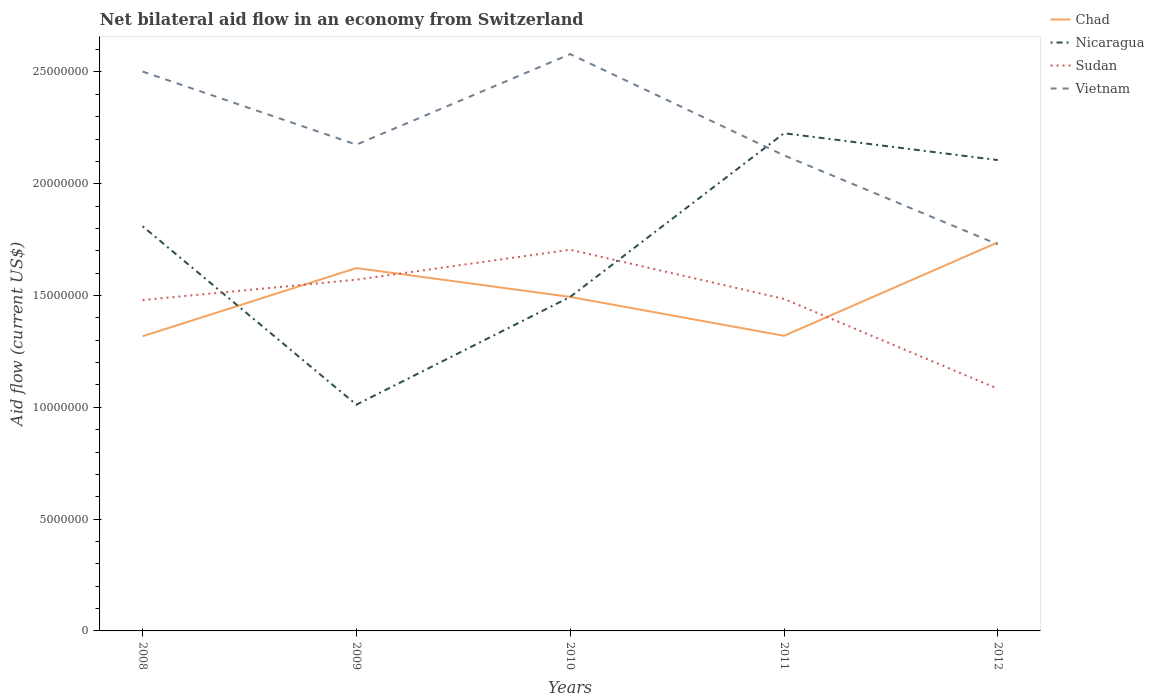How many different coloured lines are there?
Offer a very short reply. 4. Does the line corresponding to Nicaragua intersect with the line corresponding to Chad?
Keep it short and to the point. Yes. Across all years, what is the maximum net bilateral aid flow in Sudan?
Your response must be concise. 1.08e+07. In which year was the net bilateral aid flow in Nicaragua maximum?
Give a very brief answer. 2009. What is the total net bilateral aid flow in Nicaragua in the graph?
Your answer should be compact. 7.98e+06. What is the difference between the highest and the second highest net bilateral aid flow in Chad?
Your answer should be compact. 4.20e+06. How many lines are there?
Offer a very short reply. 4. Are the values on the major ticks of Y-axis written in scientific E-notation?
Your answer should be very brief. No. Does the graph contain any zero values?
Make the answer very short. No. Does the graph contain grids?
Provide a short and direct response. No. How many legend labels are there?
Make the answer very short. 4. What is the title of the graph?
Give a very brief answer. Net bilateral aid flow in an economy from Switzerland. Does "Ethiopia" appear as one of the legend labels in the graph?
Your answer should be very brief. No. What is the label or title of the X-axis?
Your answer should be very brief. Years. What is the Aid flow (current US$) of Chad in 2008?
Give a very brief answer. 1.32e+07. What is the Aid flow (current US$) of Nicaragua in 2008?
Your answer should be compact. 1.81e+07. What is the Aid flow (current US$) in Sudan in 2008?
Provide a short and direct response. 1.48e+07. What is the Aid flow (current US$) of Vietnam in 2008?
Give a very brief answer. 2.50e+07. What is the Aid flow (current US$) of Chad in 2009?
Keep it short and to the point. 1.62e+07. What is the Aid flow (current US$) of Nicaragua in 2009?
Your answer should be compact. 1.01e+07. What is the Aid flow (current US$) in Sudan in 2009?
Keep it short and to the point. 1.57e+07. What is the Aid flow (current US$) in Vietnam in 2009?
Ensure brevity in your answer.  2.18e+07. What is the Aid flow (current US$) in Chad in 2010?
Provide a succinct answer. 1.49e+07. What is the Aid flow (current US$) in Nicaragua in 2010?
Your response must be concise. 1.49e+07. What is the Aid flow (current US$) in Sudan in 2010?
Provide a succinct answer. 1.70e+07. What is the Aid flow (current US$) in Vietnam in 2010?
Keep it short and to the point. 2.58e+07. What is the Aid flow (current US$) of Chad in 2011?
Offer a very short reply. 1.32e+07. What is the Aid flow (current US$) in Nicaragua in 2011?
Provide a succinct answer. 2.23e+07. What is the Aid flow (current US$) in Sudan in 2011?
Offer a very short reply. 1.48e+07. What is the Aid flow (current US$) in Vietnam in 2011?
Offer a terse response. 2.13e+07. What is the Aid flow (current US$) of Chad in 2012?
Your response must be concise. 1.74e+07. What is the Aid flow (current US$) in Nicaragua in 2012?
Your answer should be compact. 2.11e+07. What is the Aid flow (current US$) in Sudan in 2012?
Provide a succinct answer. 1.08e+07. What is the Aid flow (current US$) in Vietnam in 2012?
Keep it short and to the point. 1.73e+07. Across all years, what is the maximum Aid flow (current US$) in Chad?
Your answer should be very brief. 1.74e+07. Across all years, what is the maximum Aid flow (current US$) of Nicaragua?
Your response must be concise. 2.23e+07. Across all years, what is the maximum Aid flow (current US$) of Sudan?
Provide a short and direct response. 1.70e+07. Across all years, what is the maximum Aid flow (current US$) of Vietnam?
Offer a very short reply. 2.58e+07. Across all years, what is the minimum Aid flow (current US$) in Chad?
Your response must be concise. 1.32e+07. Across all years, what is the minimum Aid flow (current US$) of Nicaragua?
Keep it short and to the point. 1.01e+07. Across all years, what is the minimum Aid flow (current US$) in Sudan?
Keep it short and to the point. 1.08e+07. Across all years, what is the minimum Aid flow (current US$) of Vietnam?
Your response must be concise. 1.73e+07. What is the total Aid flow (current US$) in Chad in the graph?
Make the answer very short. 7.49e+07. What is the total Aid flow (current US$) in Nicaragua in the graph?
Your answer should be very brief. 8.65e+07. What is the total Aid flow (current US$) in Sudan in the graph?
Provide a short and direct response. 7.32e+07. What is the total Aid flow (current US$) of Vietnam in the graph?
Your answer should be very brief. 1.11e+08. What is the difference between the Aid flow (current US$) of Chad in 2008 and that in 2009?
Give a very brief answer. -3.05e+06. What is the difference between the Aid flow (current US$) of Nicaragua in 2008 and that in 2009?
Your answer should be compact. 7.98e+06. What is the difference between the Aid flow (current US$) in Sudan in 2008 and that in 2009?
Make the answer very short. -9.10e+05. What is the difference between the Aid flow (current US$) of Vietnam in 2008 and that in 2009?
Offer a terse response. 3.27e+06. What is the difference between the Aid flow (current US$) of Chad in 2008 and that in 2010?
Your response must be concise. -1.76e+06. What is the difference between the Aid flow (current US$) in Nicaragua in 2008 and that in 2010?
Provide a short and direct response. 3.16e+06. What is the difference between the Aid flow (current US$) of Sudan in 2008 and that in 2010?
Your response must be concise. -2.25e+06. What is the difference between the Aid flow (current US$) in Vietnam in 2008 and that in 2010?
Ensure brevity in your answer.  -7.80e+05. What is the difference between the Aid flow (current US$) of Chad in 2008 and that in 2011?
Ensure brevity in your answer.  -2.00e+04. What is the difference between the Aid flow (current US$) in Nicaragua in 2008 and that in 2011?
Your answer should be compact. -4.16e+06. What is the difference between the Aid flow (current US$) of Vietnam in 2008 and that in 2011?
Keep it short and to the point. 3.75e+06. What is the difference between the Aid flow (current US$) of Chad in 2008 and that in 2012?
Offer a terse response. -4.20e+06. What is the difference between the Aid flow (current US$) of Nicaragua in 2008 and that in 2012?
Provide a succinct answer. -2.96e+06. What is the difference between the Aid flow (current US$) in Sudan in 2008 and that in 2012?
Your answer should be very brief. 3.97e+06. What is the difference between the Aid flow (current US$) of Vietnam in 2008 and that in 2012?
Your answer should be very brief. 7.73e+06. What is the difference between the Aid flow (current US$) of Chad in 2009 and that in 2010?
Keep it short and to the point. 1.29e+06. What is the difference between the Aid flow (current US$) of Nicaragua in 2009 and that in 2010?
Your answer should be very brief. -4.82e+06. What is the difference between the Aid flow (current US$) of Sudan in 2009 and that in 2010?
Make the answer very short. -1.34e+06. What is the difference between the Aid flow (current US$) of Vietnam in 2009 and that in 2010?
Offer a terse response. -4.05e+06. What is the difference between the Aid flow (current US$) in Chad in 2009 and that in 2011?
Give a very brief answer. 3.03e+06. What is the difference between the Aid flow (current US$) in Nicaragua in 2009 and that in 2011?
Provide a short and direct response. -1.21e+07. What is the difference between the Aid flow (current US$) of Sudan in 2009 and that in 2011?
Your answer should be compact. 8.60e+05. What is the difference between the Aid flow (current US$) in Chad in 2009 and that in 2012?
Offer a terse response. -1.15e+06. What is the difference between the Aid flow (current US$) in Nicaragua in 2009 and that in 2012?
Provide a succinct answer. -1.09e+07. What is the difference between the Aid flow (current US$) in Sudan in 2009 and that in 2012?
Give a very brief answer. 4.88e+06. What is the difference between the Aid flow (current US$) in Vietnam in 2009 and that in 2012?
Offer a terse response. 4.46e+06. What is the difference between the Aid flow (current US$) of Chad in 2010 and that in 2011?
Keep it short and to the point. 1.74e+06. What is the difference between the Aid flow (current US$) in Nicaragua in 2010 and that in 2011?
Offer a very short reply. -7.32e+06. What is the difference between the Aid flow (current US$) in Sudan in 2010 and that in 2011?
Your response must be concise. 2.20e+06. What is the difference between the Aid flow (current US$) in Vietnam in 2010 and that in 2011?
Your answer should be compact. 4.53e+06. What is the difference between the Aid flow (current US$) of Chad in 2010 and that in 2012?
Offer a very short reply. -2.44e+06. What is the difference between the Aid flow (current US$) of Nicaragua in 2010 and that in 2012?
Offer a very short reply. -6.12e+06. What is the difference between the Aid flow (current US$) of Sudan in 2010 and that in 2012?
Offer a very short reply. 6.22e+06. What is the difference between the Aid flow (current US$) of Vietnam in 2010 and that in 2012?
Keep it short and to the point. 8.51e+06. What is the difference between the Aid flow (current US$) of Chad in 2011 and that in 2012?
Provide a succinct answer. -4.18e+06. What is the difference between the Aid flow (current US$) of Nicaragua in 2011 and that in 2012?
Give a very brief answer. 1.20e+06. What is the difference between the Aid flow (current US$) of Sudan in 2011 and that in 2012?
Your response must be concise. 4.02e+06. What is the difference between the Aid flow (current US$) in Vietnam in 2011 and that in 2012?
Keep it short and to the point. 3.98e+06. What is the difference between the Aid flow (current US$) in Chad in 2008 and the Aid flow (current US$) in Nicaragua in 2009?
Ensure brevity in your answer.  3.06e+06. What is the difference between the Aid flow (current US$) of Chad in 2008 and the Aid flow (current US$) of Sudan in 2009?
Ensure brevity in your answer.  -2.53e+06. What is the difference between the Aid flow (current US$) of Chad in 2008 and the Aid flow (current US$) of Vietnam in 2009?
Your response must be concise. -8.57e+06. What is the difference between the Aid flow (current US$) in Nicaragua in 2008 and the Aid flow (current US$) in Sudan in 2009?
Keep it short and to the point. 2.39e+06. What is the difference between the Aid flow (current US$) in Nicaragua in 2008 and the Aid flow (current US$) in Vietnam in 2009?
Ensure brevity in your answer.  -3.65e+06. What is the difference between the Aid flow (current US$) of Sudan in 2008 and the Aid flow (current US$) of Vietnam in 2009?
Make the answer very short. -6.95e+06. What is the difference between the Aid flow (current US$) of Chad in 2008 and the Aid flow (current US$) of Nicaragua in 2010?
Offer a terse response. -1.76e+06. What is the difference between the Aid flow (current US$) in Chad in 2008 and the Aid flow (current US$) in Sudan in 2010?
Provide a short and direct response. -3.87e+06. What is the difference between the Aid flow (current US$) in Chad in 2008 and the Aid flow (current US$) in Vietnam in 2010?
Your response must be concise. -1.26e+07. What is the difference between the Aid flow (current US$) in Nicaragua in 2008 and the Aid flow (current US$) in Sudan in 2010?
Offer a terse response. 1.05e+06. What is the difference between the Aid flow (current US$) of Nicaragua in 2008 and the Aid flow (current US$) of Vietnam in 2010?
Give a very brief answer. -7.70e+06. What is the difference between the Aid flow (current US$) of Sudan in 2008 and the Aid flow (current US$) of Vietnam in 2010?
Keep it short and to the point. -1.10e+07. What is the difference between the Aid flow (current US$) of Chad in 2008 and the Aid flow (current US$) of Nicaragua in 2011?
Provide a short and direct response. -9.08e+06. What is the difference between the Aid flow (current US$) in Chad in 2008 and the Aid flow (current US$) in Sudan in 2011?
Make the answer very short. -1.67e+06. What is the difference between the Aid flow (current US$) of Chad in 2008 and the Aid flow (current US$) of Vietnam in 2011?
Offer a very short reply. -8.09e+06. What is the difference between the Aid flow (current US$) of Nicaragua in 2008 and the Aid flow (current US$) of Sudan in 2011?
Provide a short and direct response. 3.25e+06. What is the difference between the Aid flow (current US$) of Nicaragua in 2008 and the Aid flow (current US$) of Vietnam in 2011?
Your response must be concise. -3.17e+06. What is the difference between the Aid flow (current US$) in Sudan in 2008 and the Aid flow (current US$) in Vietnam in 2011?
Keep it short and to the point. -6.47e+06. What is the difference between the Aid flow (current US$) in Chad in 2008 and the Aid flow (current US$) in Nicaragua in 2012?
Make the answer very short. -7.88e+06. What is the difference between the Aid flow (current US$) of Chad in 2008 and the Aid flow (current US$) of Sudan in 2012?
Keep it short and to the point. 2.35e+06. What is the difference between the Aid flow (current US$) in Chad in 2008 and the Aid flow (current US$) in Vietnam in 2012?
Keep it short and to the point. -4.11e+06. What is the difference between the Aid flow (current US$) of Nicaragua in 2008 and the Aid flow (current US$) of Sudan in 2012?
Keep it short and to the point. 7.27e+06. What is the difference between the Aid flow (current US$) of Nicaragua in 2008 and the Aid flow (current US$) of Vietnam in 2012?
Keep it short and to the point. 8.10e+05. What is the difference between the Aid flow (current US$) of Sudan in 2008 and the Aid flow (current US$) of Vietnam in 2012?
Your response must be concise. -2.49e+06. What is the difference between the Aid flow (current US$) of Chad in 2009 and the Aid flow (current US$) of Nicaragua in 2010?
Provide a succinct answer. 1.29e+06. What is the difference between the Aid flow (current US$) of Chad in 2009 and the Aid flow (current US$) of Sudan in 2010?
Offer a terse response. -8.20e+05. What is the difference between the Aid flow (current US$) of Chad in 2009 and the Aid flow (current US$) of Vietnam in 2010?
Provide a short and direct response. -9.57e+06. What is the difference between the Aid flow (current US$) in Nicaragua in 2009 and the Aid flow (current US$) in Sudan in 2010?
Your answer should be compact. -6.93e+06. What is the difference between the Aid flow (current US$) of Nicaragua in 2009 and the Aid flow (current US$) of Vietnam in 2010?
Your answer should be very brief. -1.57e+07. What is the difference between the Aid flow (current US$) in Sudan in 2009 and the Aid flow (current US$) in Vietnam in 2010?
Ensure brevity in your answer.  -1.01e+07. What is the difference between the Aid flow (current US$) of Chad in 2009 and the Aid flow (current US$) of Nicaragua in 2011?
Offer a terse response. -6.03e+06. What is the difference between the Aid flow (current US$) of Chad in 2009 and the Aid flow (current US$) of Sudan in 2011?
Offer a terse response. 1.38e+06. What is the difference between the Aid flow (current US$) in Chad in 2009 and the Aid flow (current US$) in Vietnam in 2011?
Your answer should be very brief. -5.04e+06. What is the difference between the Aid flow (current US$) in Nicaragua in 2009 and the Aid flow (current US$) in Sudan in 2011?
Keep it short and to the point. -4.73e+06. What is the difference between the Aid flow (current US$) of Nicaragua in 2009 and the Aid flow (current US$) of Vietnam in 2011?
Your response must be concise. -1.12e+07. What is the difference between the Aid flow (current US$) of Sudan in 2009 and the Aid flow (current US$) of Vietnam in 2011?
Give a very brief answer. -5.56e+06. What is the difference between the Aid flow (current US$) of Chad in 2009 and the Aid flow (current US$) of Nicaragua in 2012?
Offer a terse response. -4.83e+06. What is the difference between the Aid flow (current US$) of Chad in 2009 and the Aid flow (current US$) of Sudan in 2012?
Your response must be concise. 5.40e+06. What is the difference between the Aid flow (current US$) of Chad in 2009 and the Aid flow (current US$) of Vietnam in 2012?
Your answer should be very brief. -1.06e+06. What is the difference between the Aid flow (current US$) of Nicaragua in 2009 and the Aid flow (current US$) of Sudan in 2012?
Give a very brief answer. -7.10e+05. What is the difference between the Aid flow (current US$) in Nicaragua in 2009 and the Aid flow (current US$) in Vietnam in 2012?
Keep it short and to the point. -7.17e+06. What is the difference between the Aid flow (current US$) of Sudan in 2009 and the Aid flow (current US$) of Vietnam in 2012?
Give a very brief answer. -1.58e+06. What is the difference between the Aid flow (current US$) of Chad in 2010 and the Aid flow (current US$) of Nicaragua in 2011?
Provide a succinct answer. -7.32e+06. What is the difference between the Aid flow (current US$) in Chad in 2010 and the Aid flow (current US$) in Sudan in 2011?
Make the answer very short. 9.00e+04. What is the difference between the Aid flow (current US$) of Chad in 2010 and the Aid flow (current US$) of Vietnam in 2011?
Keep it short and to the point. -6.33e+06. What is the difference between the Aid flow (current US$) in Nicaragua in 2010 and the Aid flow (current US$) in Sudan in 2011?
Make the answer very short. 9.00e+04. What is the difference between the Aid flow (current US$) of Nicaragua in 2010 and the Aid flow (current US$) of Vietnam in 2011?
Provide a short and direct response. -6.33e+06. What is the difference between the Aid flow (current US$) in Sudan in 2010 and the Aid flow (current US$) in Vietnam in 2011?
Give a very brief answer. -4.22e+06. What is the difference between the Aid flow (current US$) in Chad in 2010 and the Aid flow (current US$) in Nicaragua in 2012?
Make the answer very short. -6.12e+06. What is the difference between the Aid flow (current US$) of Chad in 2010 and the Aid flow (current US$) of Sudan in 2012?
Give a very brief answer. 4.11e+06. What is the difference between the Aid flow (current US$) of Chad in 2010 and the Aid flow (current US$) of Vietnam in 2012?
Offer a very short reply. -2.35e+06. What is the difference between the Aid flow (current US$) of Nicaragua in 2010 and the Aid flow (current US$) of Sudan in 2012?
Ensure brevity in your answer.  4.11e+06. What is the difference between the Aid flow (current US$) in Nicaragua in 2010 and the Aid flow (current US$) in Vietnam in 2012?
Give a very brief answer. -2.35e+06. What is the difference between the Aid flow (current US$) of Sudan in 2010 and the Aid flow (current US$) of Vietnam in 2012?
Your answer should be compact. -2.40e+05. What is the difference between the Aid flow (current US$) of Chad in 2011 and the Aid flow (current US$) of Nicaragua in 2012?
Your answer should be very brief. -7.86e+06. What is the difference between the Aid flow (current US$) of Chad in 2011 and the Aid flow (current US$) of Sudan in 2012?
Your answer should be compact. 2.37e+06. What is the difference between the Aid flow (current US$) in Chad in 2011 and the Aid flow (current US$) in Vietnam in 2012?
Keep it short and to the point. -4.09e+06. What is the difference between the Aid flow (current US$) of Nicaragua in 2011 and the Aid flow (current US$) of Sudan in 2012?
Your answer should be very brief. 1.14e+07. What is the difference between the Aid flow (current US$) of Nicaragua in 2011 and the Aid flow (current US$) of Vietnam in 2012?
Your answer should be very brief. 4.97e+06. What is the difference between the Aid flow (current US$) of Sudan in 2011 and the Aid flow (current US$) of Vietnam in 2012?
Your response must be concise. -2.44e+06. What is the average Aid flow (current US$) of Chad per year?
Offer a very short reply. 1.50e+07. What is the average Aid flow (current US$) in Nicaragua per year?
Make the answer very short. 1.73e+07. What is the average Aid flow (current US$) in Sudan per year?
Provide a short and direct response. 1.46e+07. What is the average Aid flow (current US$) of Vietnam per year?
Ensure brevity in your answer.  2.22e+07. In the year 2008, what is the difference between the Aid flow (current US$) of Chad and Aid flow (current US$) of Nicaragua?
Offer a very short reply. -4.92e+06. In the year 2008, what is the difference between the Aid flow (current US$) of Chad and Aid flow (current US$) of Sudan?
Offer a very short reply. -1.62e+06. In the year 2008, what is the difference between the Aid flow (current US$) of Chad and Aid flow (current US$) of Vietnam?
Your response must be concise. -1.18e+07. In the year 2008, what is the difference between the Aid flow (current US$) of Nicaragua and Aid flow (current US$) of Sudan?
Your response must be concise. 3.30e+06. In the year 2008, what is the difference between the Aid flow (current US$) in Nicaragua and Aid flow (current US$) in Vietnam?
Make the answer very short. -6.92e+06. In the year 2008, what is the difference between the Aid flow (current US$) in Sudan and Aid flow (current US$) in Vietnam?
Your answer should be compact. -1.02e+07. In the year 2009, what is the difference between the Aid flow (current US$) of Chad and Aid flow (current US$) of Nicaragua?
Your answer should be very brief. 6.11e+06. In the year 2009, what is the difference between the Aid flow (current US$) of Chad and Aid flow (current US$) of Sudan?
Make the answer very short. 5.20e+05. In the year 2009, what is the difference between the Aid flow (current US$) in Chad and Aid flow (current US$) in Vietnam?
Your answer should be very brief. -5.52e+06. In the year 2009, what is the difference between the Aid flow (current US$) of Nicaragua and Aid flow (current US$) of Sudan?
Your answer should be very brief. -5.59e+06. In the year 2009, what is the difference between the Aid flow (current US$) in Nicaragua and Aid flow (current US$) in Vietnam?
Make the answer very short. -1.16e+07. In the year 2009, what is the difference between the Aid flow (current US$) in Sudan and Aid flow (current US$) in Vietnam?
Your answer should be very brief. -6.04e+06. In the year 2010, what is the difference between the Aid flow (current US$) in Chad and Aid flow (current US$) in Nicaragua?
Provide a succinct answer. 0. In the year 2010, what is the difference between the Aid flow (current US$) of Chad and Aid flow (current US$) of Sudan?
Give a very brief answer. -2.11e+06. In the year 2010, what is the difference between the Aid flow (current US$) of Chad and Aid flow (current US$) of Vietnam?
Provide a succinct answer. -1.09e+07. In the year 2010, what is the difference between the Aid flow (current US$) in Nicaragua and Aid flow (current US$) in Sudan?
Offer a very short reply. -2.11e+06. In the year 2010, what is the difference between the Aid flow (current US$) of Nicaragua and Aid flow (current US$) of Vietnam?
Offer a very short reply. -1.09e+07. In the year 2010, what is the difference between the Aid flow (current US$) of Sudan and Aid flow (current US$) of Vietnam?
Provide a succinct answer. -8.75e+06. In the year 2011, what is the difference between the Aid flow (current US$) of Chad and Aid flow (current US$) of Nicaragua?
Ensure brevity in your answer.  -9.06e+06. In the year 2011, what is the difference between the Aid flow (current US$) in Chad and Aid flow (current US$) in Sudan?
Provide a short and direct response. -1.65e+06. In the year 2011, what is the difference between the Aid flow (current US$) in Chad and Aid flow (current US$) in Vietnam?
Offer a terse response. -8.07e+06. In the year 2011, what is the difference between the Aid flow (current US$) of Nicaragua and Aid flow (current US$) of Sudan?
Your answer should be very brief. 7.41e+06. In the year 2011, what is the difference between the Aid flow (current US$) of Nicaragua and Aid flow (current US$) of Vietnam?
Make the answer very short. 9.90e+05. In the year 2011, what is the difference between the Aid flow (current US$) in Sudan and Aid flow (current US$) in Vietnam?
Give a very brief answer. -6.42e+06. In the year 2012, what is the difference between the Aid flow (current US$) in Chad and Aid flow (current US$) in Nicaragua?
Give a very brief answer. -3.68e+06. In the year 2012, what is the difference between the Aid flow (current US$) in Chad and Aid flow (current US$) in Sudan?
Provide a succinct answer. 6.55e+06. In the year 2012, what is the difference between the Aid flow (current US$) of Nicaragua and Aid flow (current US$) of Sudan?
Give a very brief answer. 1.02e+07. In the year 2012, what is the difference between the Aid flow (current US$) in Nicaragua and Aid flow (current US$) in Vietnam?
Provide a short and direct response. 3.77e+06. In the year 2012, what is the difference between the Aid flow (current US$) in Sudan and Aid flow (current US$) in Vietnam?
Ensure brevity in your answer.  -6.46e+06. What is the ratio of the Aid flow (current US$) of Chad in 2008 to that in 2009?
Provide a succinct answer. 0.81. What is the ratio of the Aid flow (current US$) of Nicaragua in 2008 to that in 2009?
Make the answer very short. 1.79. What is the ratio of the Aid flow (current US$) in Sudan in 2008 to that in 2009?
Your response must be concise. 0.94. What is the ratio of the Aid flow (current US$) in Vietnam in 2008 to that in 2009?
Your answer should be very brief. 1.15. What is the ratio of the Aid flow (current US$) of Chad in 2008 to that in 2010?
Your answer should be compact. 0.88. What is the ratio of the Aid flow (current US$) in Nicaragua in 2008 to that in 2010?
Provide a succinct answer. 1.21. What is the ratio of the Aid flow (current US$) in Sudan in 2008 to that in 2010?
Your answer should be very brief. 0.87. What is the ratio of the Aid flow (current US$) in Vietnam in 2008 to that in 2010?
Your answer should be compact. 0.97. What is the ratio of the Aid flow (current US$) of Nicaragua in 2008 to that in 2011?
Your response must be concise. 0.81. What is the ratio of the Aid flow (current US$) of Vietnam in 2008 to that in 2011?
Offer a terse response. 1.18. What is the ratio of the Aid flow (current US$) of Chad in 2008 to that in 2012?
Provide a short and direct response. 0.76. What is the ratio of the Aid flow (current US$) of Nicaragua in 2008 to that in 2012?
Your response must be concise. 0.86. What is the ratio of the Aid flow (current US$) of Sudan in 2008 to that in 2012?
Offer a very short reply. 1.37. What is the ratio of the Aid flow (current US$) in Vietnam in 2008 to that in 2012?
Your answer should be very brief. 1.45. What is the ratio of the Aid flow (current US$) of Chad in 2009 to that in 2010?
Offer a very short reply. 1.09. What is the ratio of the Aid flow (current US$) of Nicaragua in 2009 to that in 2010?
Offer a terse response. 0.68. What is the ratio of the Aid flow (current US$) of Sudan in 2009 to that in 2010?
Offer a very short reply. 0.92. What is the ratio of the Aid flow (current US$) of Vietnam in 2009 to that in 2010?
Your answer should be compact. 0.84. What is the ratio of the Aid flow (current US$) of Chad in 2009 to that in 2011?
Give a very brief answer. 1.23. What is the ratio of the Aid flow (current US$) in Nicaragua in 2009 to that in 2011?
Give a very brief answer. 0.45. What is the ratio of the Aid flow (current US$) of Sudan in 2009 to that in 2011?
Provide a short and direct response. 1.06. What is the ratio of the Aid flow (current US$) of Vietnam in 2009 to that in 2011?
Make the answer very short. 1.02. What is the ratio of the Aid flow (current US$) of Chad in 2009 to that in 2012?
Ensure brevity in your answer.  0.93. What is the ratio of the Aid flow (current US$) of Nicaragua in 2009 to that in 2012?
Your answer should be compact. 0.48. What is the ratio of the Aid flow (current US$) of Sudan in 2009 to that in 2012?
Your answer should be compact. 1.45. What is the ratio of the Aid flow (current US$) of Vietnam in 2009 to that in 2012?
Give a very brief answer. 1.26. What is the ratio of the Aid flow (current US$) of Chad in 2010 to that in 2011?
Ensure brevity in your answer.  1.13. What is the ratio of the Aid flow (current US$) of Nicaragua in 2010 to that in 2011?
Make the answer very short. 0.67. What is the ratio of the Aid flow (current US$) of Sudan in 2010 to that in 2011?
Offer a terse response. 1.15. What is the ratio of the Aid flow (current US$) of Vietnam in 2010 to that in 2011?
Offer a terse response. 1.21. What is the ratio of the Aid flow (current US$) in Chad in 2010 to that in 2012?
Offer a terse response. 0.86. What is the ratio of the Aid flow (current US$) of Nicaragua in 2010 to that in 2012?
Your answer should be compact. 0.71. What is the ratio of the Aid flow (current US$) in Sudan in 2010 to that in 2012?
Your answer should be compact. 1.57. What is the ratio of the Aid flow (current US$) of Vietnam in 2010 to that in 2012?
Ensure brevity in your answer.  1.49. What is the ratio of the Aid flow (current US$) in Chad in 2011 to that in 2012?
Your answer should be very brief. 0.76. What is the ratio of the Aid flow (current US$) of Nicaragua in 2011 to that in 2012?
Offer a terse response. 1.06. What is the ratio of the Aid flow (current US$) of Sudan in 2011 to that in 2012?
Offer a terse response. 1.37. What is the ratio of the Aid flow (current US$) in Vietnam in 2011 to that in 2012?
Your answer should be very brief. 1.23. What is the difference between the highest and the second highest Aid flow (current US$) in Chad?
Provide a succinct answer. 1.15e+06. What is the difference between the highest and the second highest Aid flow (current US$) of Nicaragua?
Keep it short and to the point. 1.20e+06. What is the difference between the highest and the second highest Aid flow (current US$) in Sudan?
Your response must be concise. 1.34e+06. What is the difference between the highest and the second highest Aid flow (current US$) of Vietnam?
Give a very brief answer. 7.80e+05. What is the difference between the highest and the lowest Aid flow (current US$) of Chad?
Keep it short and to the point. 4.20e+06. What is the difference between the highest and the lowest Aid flow (current US$) in Nicaragua?
Make the answer very short. 1.21e+07. What is the difference between the highest and the lowest Aid flow (current US$) in Sudan?
Keep it short and to the point. 6.22e+06. What is the difference between the highest and the lowest Aid flow (current US$) in Vietnam?
Your answer should be compact. 8.51e+06. 